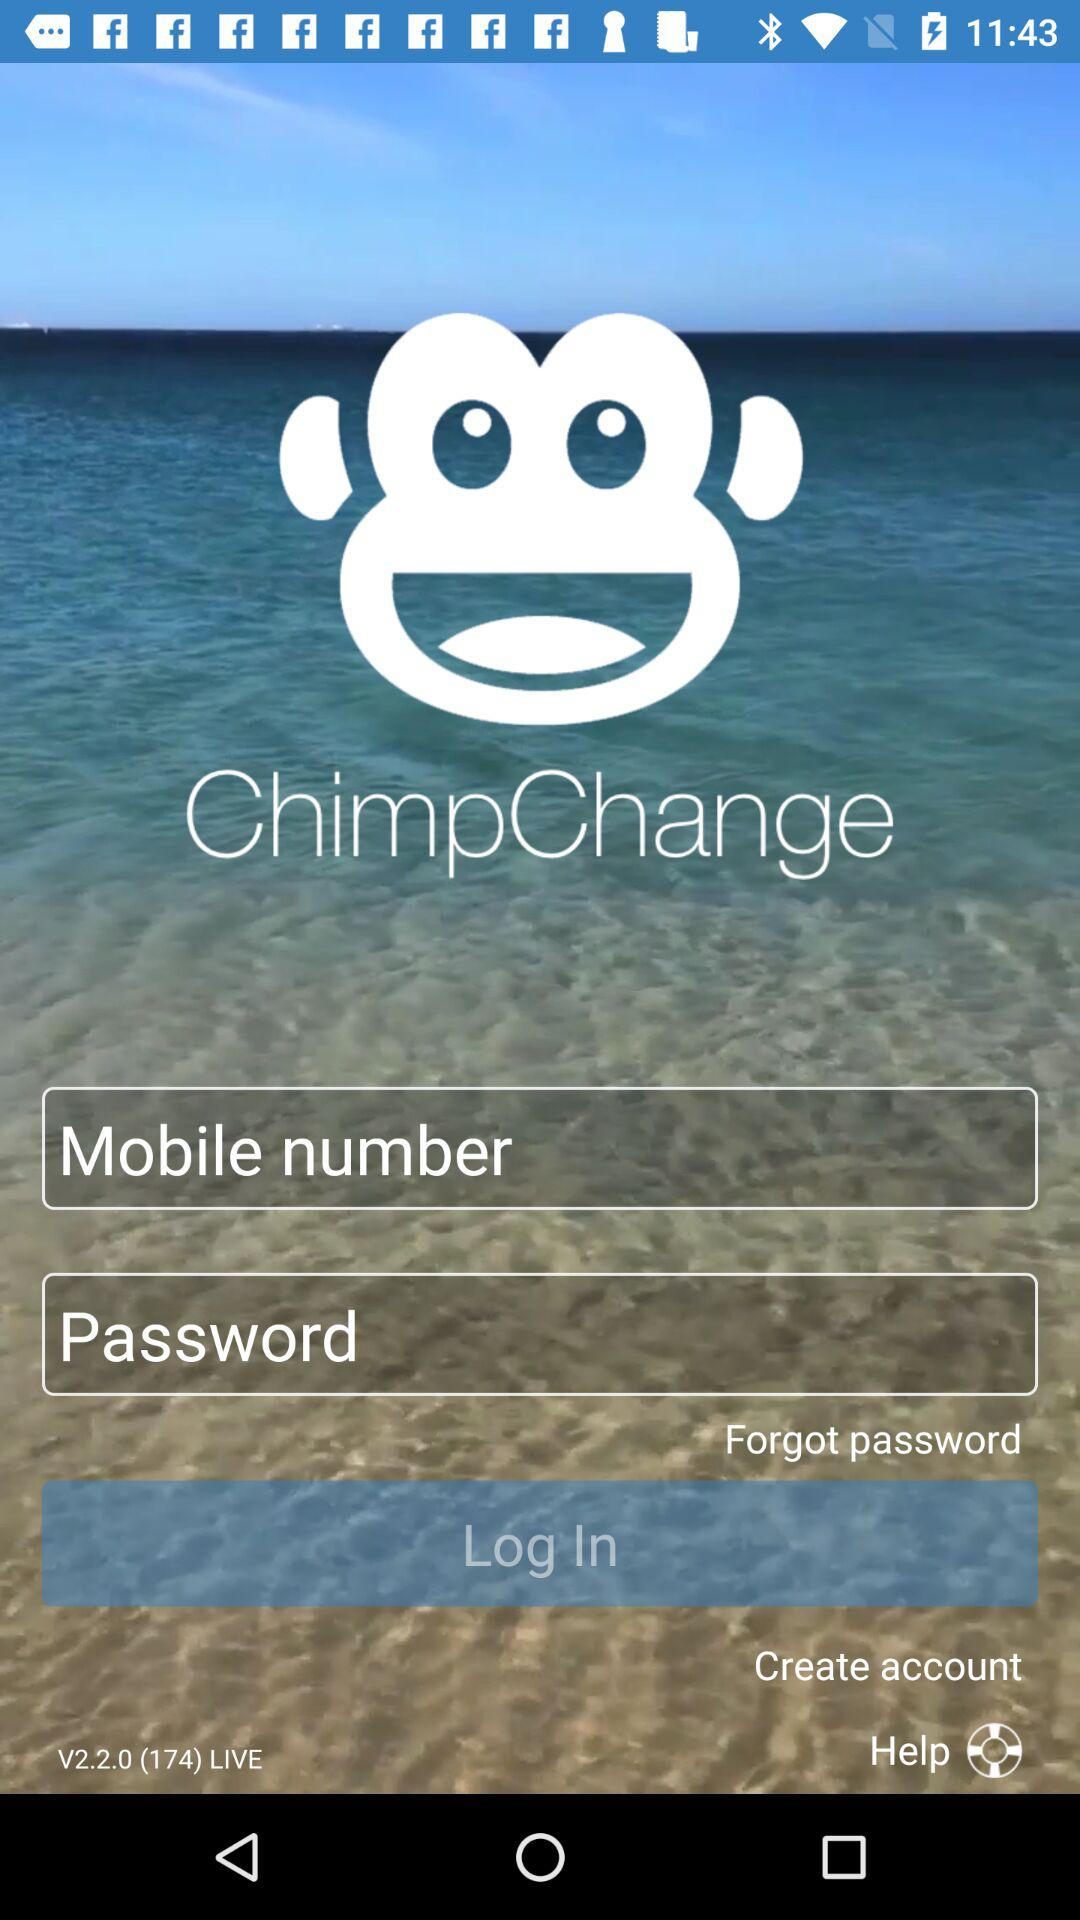What is the version of the application?
Answer the question using a single word or phrase. The version is 2.2.0 